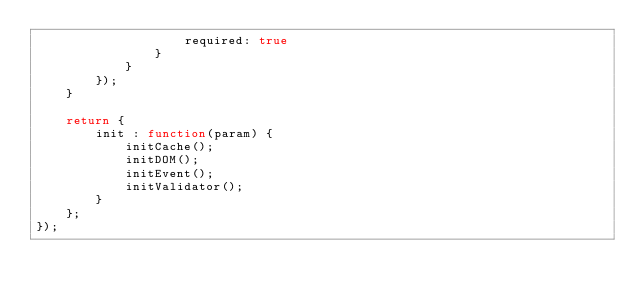Convert code to text. <code><loc_0><loc_0><loc_500><loc_500><_JavaScript_>                    required: true
                }
            }
        });
    }

	return {
		init : function(param) {
			initCache();
			initDOM();
			initEvent();
            initValidator();
		}
    };
});</code> 